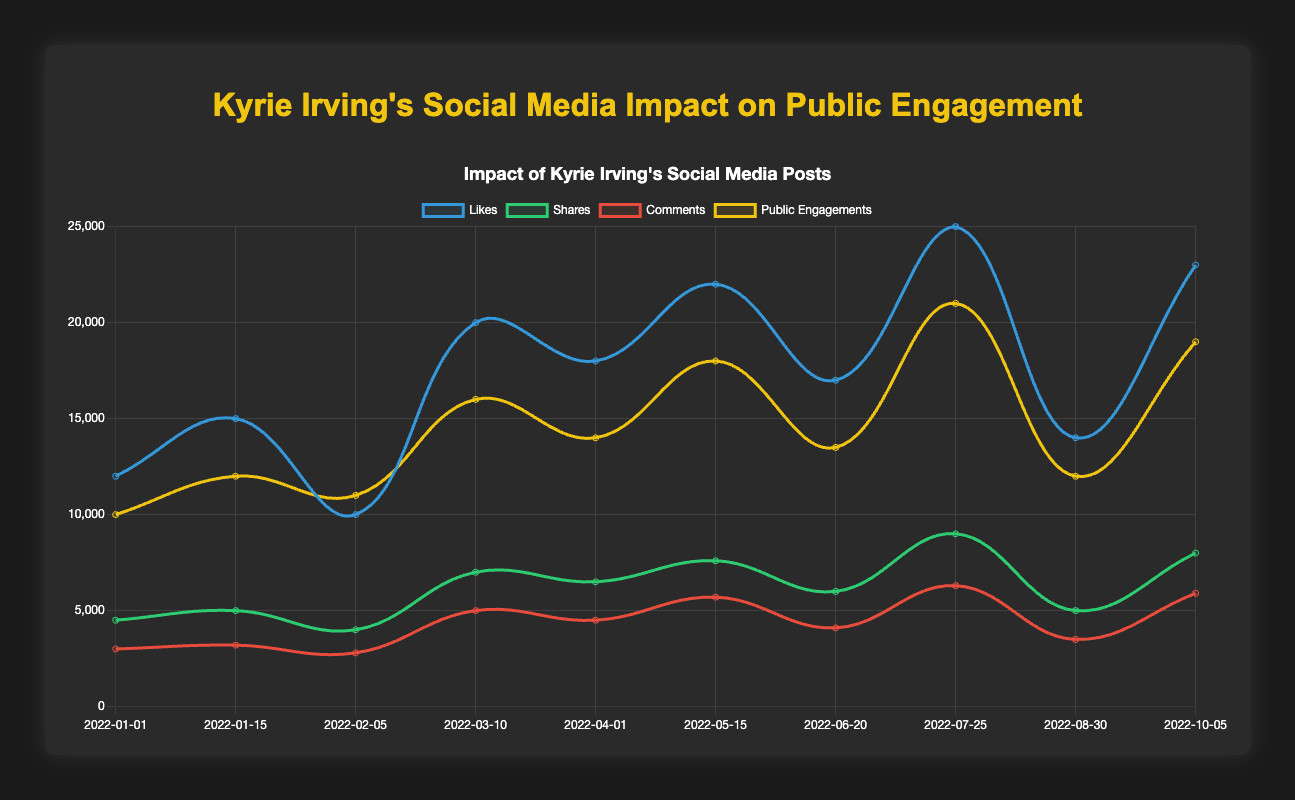Which post had the highest number of likes? The "Police Brutality" post on 2022-07-25 had the highest number of likes.
Answer: Police Brutality Which post generated the most public engagements? The "Police Brutality" post on 2022-07-25 also generated the most public engagements with 21000 engagements.
Answer: Police Brutality How many likes did the "Mental Health Awareness" post receive? The "Mental Health Awareness" post on 2022-04-01 received 18000 likes.
Answer: 18000 Which post had higher public engagements, "Anti-Asian Hate" or "Gender Equality"? "Anti-Asian Hate" had 16000 public engagements, while "Gender Equality" had 13500 public engagements. Thus, "Anti-Asian Hate" had higher public engagements.
Answer: Anti-Asian Hate What is the average number of shares across all topics? To find the average: sum the shares (4500 + 5000 + 4000 + 7000 + 6500 + 7600 + 6000 + 9000 + 5000 + 8000) = 62600. Divide by the number of data points (10), so 62600 / 10 = 6260.
Answer: 6260 Compare the number of comments on "Educational Opportunities for Underserved Communities" and "LGBTQ+ Rights". The "Educational Opportunities for Underserved Communities" post had 5700 comments, and the "LGBTQ+ Rights" post had 5900 comments. Thus, "LGBTQ+ Rights" had more comments.
Answer: LGBTQ+ Rights Which visual indicator (likes, shares, comments, public engagements) showed the most significant peak for "Anti-Asian Hate"? The "Anti-Asian Hate" post on 2022-03-10 showed the highest peak in the "likes" category with 20000 likes.
Answer: likes How many more likes did the "Educational Opportunities for Underserved Communities" post receive compared to "Health Care Access"? "Educational Opportunities for Underserved Communities" received 22000 likes, and "Health Care Access" received 14000 likes. The difference is 22000 - 14000 = 8000 likes.
Answer: 8000 